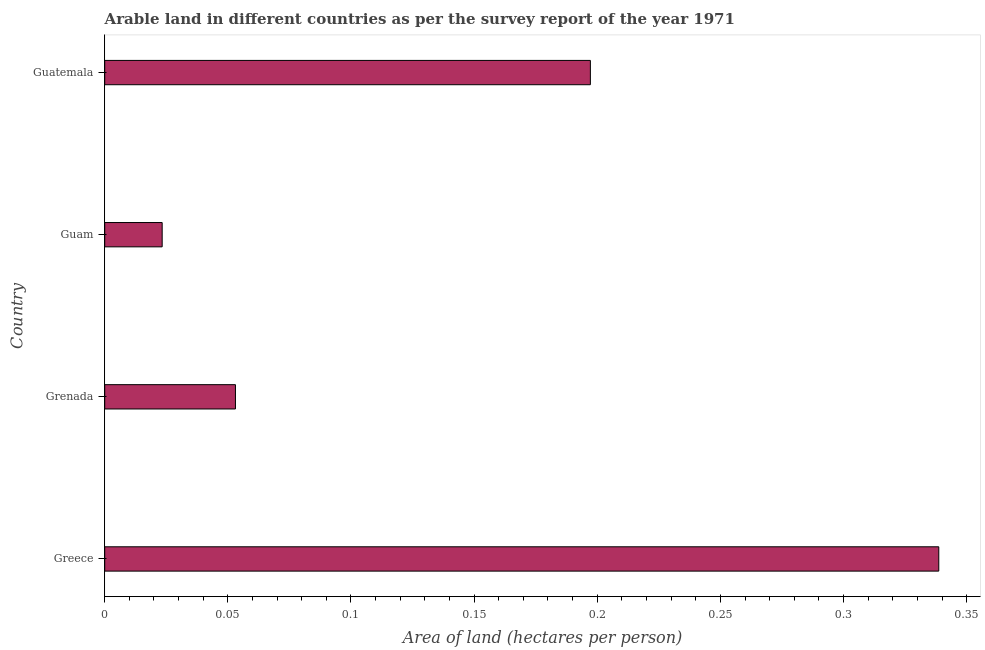What is the title of the graph?
Make the answer very short. Arable land in different countries as per the survey report of the year 1971. What is the label or title of the X-axis?
Provide a short and direct response. Area of land (hectares per person). What is the label or title of the Y-axis?
Your answer should be compact. Country. What is the area of arable land in Guatemala?
Offer a very short reply. 0.2. Across all countries, what is the maximum area of arable land?
Ensure brevity in your answer.  0.34. Across all countries, what is the minimum area of arable land?
Your answer should be very brief. 0.02. In which country was the area of arable land maximum?
Offer a very short reply. Greece. In which country was the area of arable land minimum?
Make the answer very short. Guam. What is the sum of the area of arable land?
Offer a very short reply. 0.61. What is the difference between the area of arable land in Grenada and Guatemala?
Your answer should be very brief. -0.14. What is the average area of arable land per country?
Offer a terse response. 0.15. What is the median area of arable land?
Offer a terse response. 0.13. In how many countries, is the area of arable land greater than 0.23 hectares per person?
Give a very brief answer. 1. What is the ratio of the area of arable land in Greece to that in Guam?
Your response must be concise. 14.52. Is the difference between the area of arable land in Greece and Guatemala greater than the difference between any two countries?
Offer a very short reply. No. What is the difference between the highest and the second highest area of arable land?
Provide a short and direct response. 0.14. What is the difference between the highest and the lowest area of arable land?
Your answer should be compact. 0.32. Are all the bars in the graph horizontal?
Provide a succinct answer. Yes. How many countries are there in the graph?
Provide a succinct answer. 4. What is the difference between two consecutive major ticks on the X-axis?
Provide a succinct answer. 0.05. Are the values on the major ticks of X-axis written in scientific E-notation?
Provide a short and direct response. No. What is the Area of land (hectares per person) of Greece?
Your answer should be very brief. 0.34. What is the Area of land (hectares per person) of Grenada?
Ensure brevity in your answer.  0.05. What is the Area of land (hectares per person) of Guam?
Keep it short and to the point. 0.02. What is the Area of land (hectares per person) in Guatemala?
Your response must be concise. 0.2. What is the difference between the Area of land (hectares per person) in Greece and Grenada?
Provide a short and direct response. 0.29. What is the difference between the Area of land (hectares per person) in Greece and Guam?
Provide a short and direct response. 0.32. What is the difference between the Area of land (hectares per person) in Greece and Guatemala?
Your answer should be very brief. 0.14. What is the difference between the Area of land (hectares per person) in Grenada and Guam?
Offer a terse response. 0.03. What is the difference between the Area of land (hectares per person) in Grenada and Guatemala?
Your answer should be compact. -0.14. What is the difference between the Area of land (hectares per person) in Guam and Guatemala?
Your response must be concise. -0.17. What is the ratio of the Area of land (hectares per person) in Greece to that in Grenada?
Your answer should be very brief. 6.38. What is the ratio of the Area of land (hectares per person) in Greece to that in Guam?
Your response must be concise. 14.52. What is the ratio of the Area of land (hectares per person) in Greece to that in Guatemala?
Provide a short and direct response. 1.72. What is the ratio of the Area of land (hectares per person) in Grenada to that in Guam?
Provide a succinct answer. 2.28. What is the ratio of the Area of land (hectares per person) in Grenada to that in Guatemala?
Give a very brief answer. 0.27. What is the ratio of the Area of land (hectares per person) in Guam to that in Guatemala?
Your response must be concise. 0.12. 